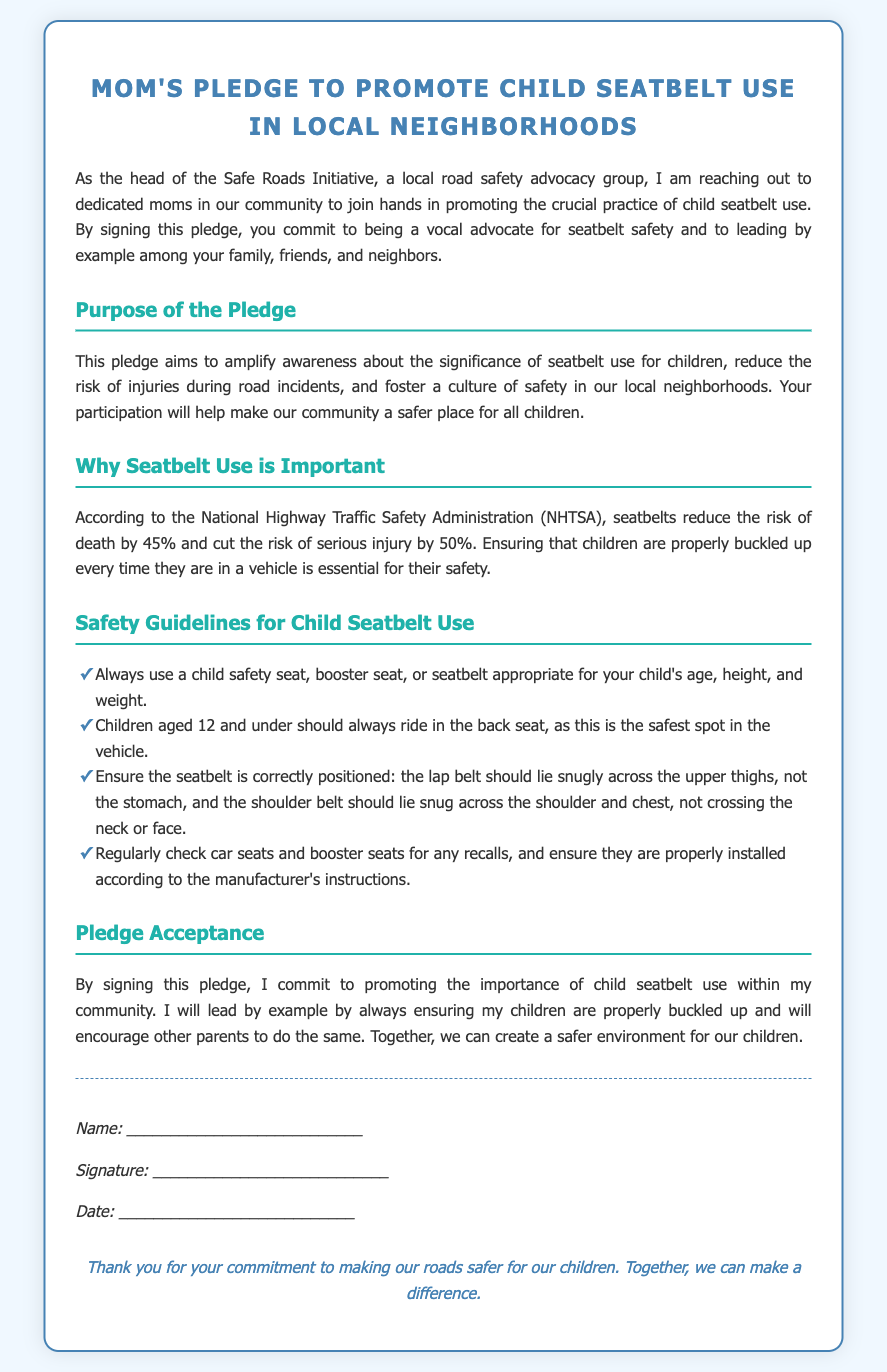What is the title of the document? The title of the document is indicated at the top, which reflects the pledge focus.
Answer: Mom's Pledge to Promote Child Seatbelt Use in Local Neighborhoods What organization is leading this initiative? The organization coordinating this pledge is mentioned in the introduction section, focusing on local road safety.
Answer: Safe Roads Initiative What percentage does seatbelt use reduce the risk of death according to NHTSA? The document provides specific statistical data regarding seatbelt effectiveness referenced from NHTSA.
Answer: 45% What is one of the safety guidelines for child seatbelt use? The guidelines are listed to ensure proper child safety; one is selected from this list.
Answer: Always use a child safety seat appropriate for your child's age Who should always ride in the back seat? The document specifies who should be seated where in the vehicle for safety reasons.
Answer: Children aged 12 and under What does signing the pledge signify? The significance of signing the document expresses a commitment and action outlined in the pledge acceptance.
Answer: Commitment to promoting child seatbelt use 